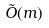Convert formula to latex. <formula><loc_0><loc_0><loc_500><loc_500>\tilde { O } ( m )</formula> 